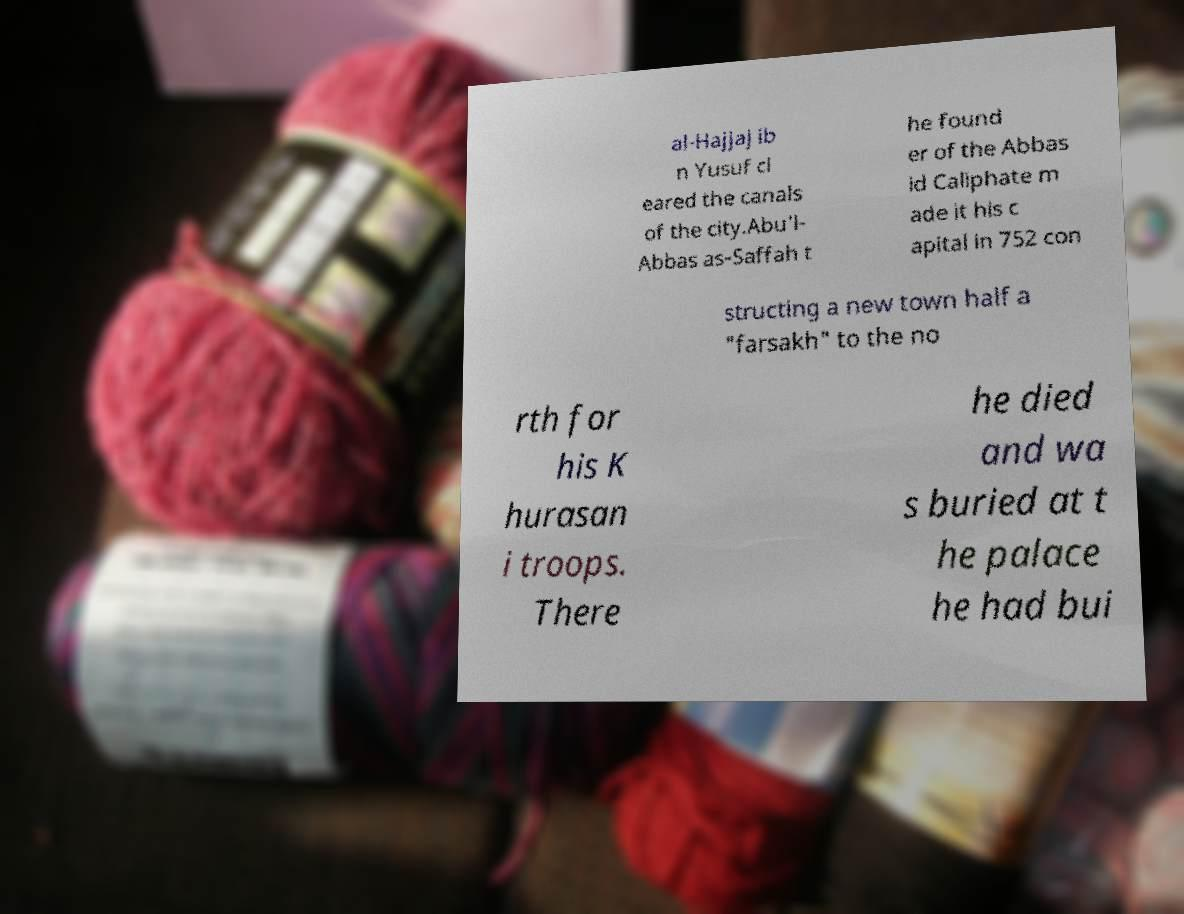Could you extract and type out the text from this image? al-Hajjaj ib n Yusuf cl eared the canals of the city.Abu'l- Abbas as-Saffah t he found er of the Abbas id Caliphate m ade it his c apital in 752 con structing a new town half a "farsakh" to the no rth for his K hurasan i troops. There he died and wa s buried at t he palace he had bui 